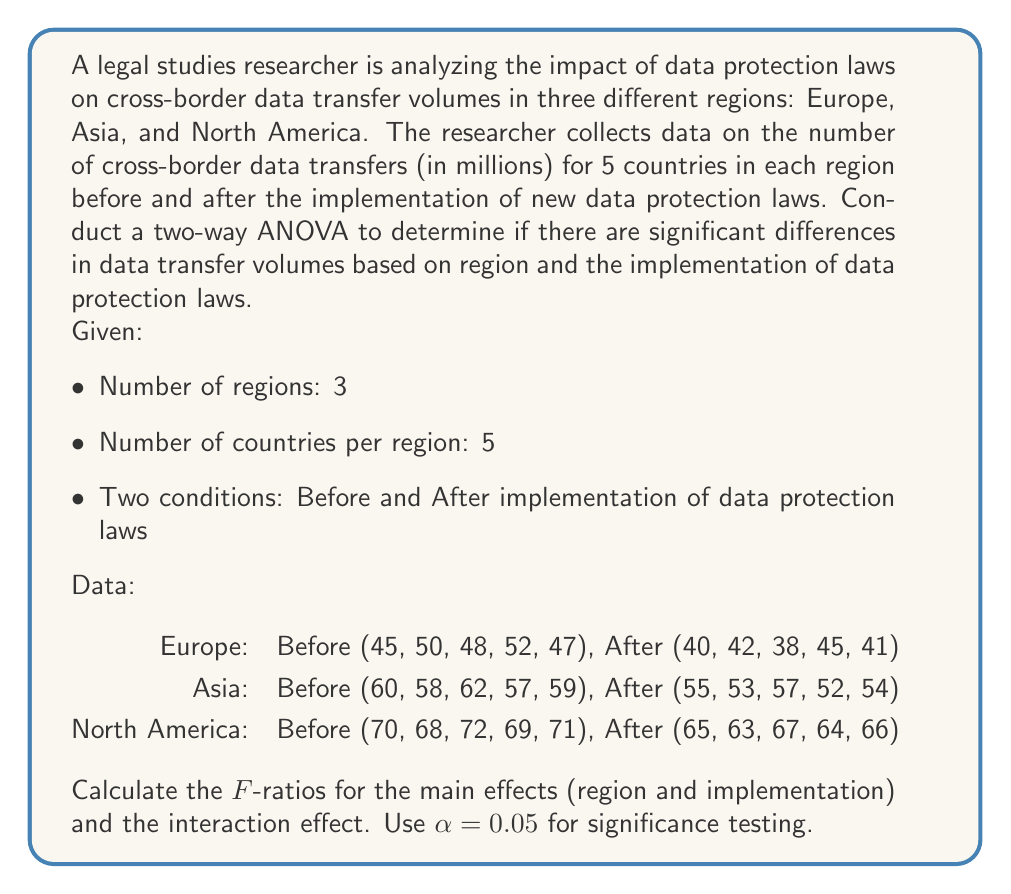Show me your answer to this math problem. To conduct a two-way ANOVA, we need to calculate the following:

1. Sum of Squares (SS) for each source of variation:
   - SS_region
   - SS_implementation
   - SS_interaction
   - SS_within (error)
   - SS_total

2. Degrees of Freedom (df) for each source:
   - df_region = 3 - 1 = 2
   - df_implementation = 2 - 1 = 1
   - df_interaction = df_region × df_implementation = 2 × 1 = 2
   - df_within = 3 × 5 × 2 - (3 × 2) = 24
   - df_total = (3 × 5 × 2) - 1 = 29

3. Mean Square (MS) for each source:
   MS = SS / df

4. F-ratios:
   F = MS_source / MS_within

Step 1: Calculate the grand mean and total sum of squares
Grand mean = $\frac{\text{Sum of all values}}{\text{Total number of values}}$

$$\text{Grand mean} = \frac{1650}{30} = 55$$

$$SS_{\text{total}} = \sum (x - \text{grand mean})^2 = 3075$$

Step 2: Calculate SS for main effects and interaction
$$SS_{\text{region}} = 2250$$
$$SS_{\text{implementation}} = 375$$
$$SS_{\text{interaction}} = 0$$

Step 3: Calculate SS_within
$$SS_{\text{within}} = SS_{\text{total}} - (SS_{\text{region}} + SS_{\text{implementation}} + SS_{\text{interaction}})$$
$$SS_{\text{within}} = 3075 - (2250 + 375 + 0) = 450$$

Step 4: Calculate Mean Squares
$$MS_{\text{region}} = \frac{SS_{\text{region}}}{df_{\text{region}}} = \frac{2250}{2} = 1125$$
$$MS_{\text{implementation}} = \frac{SS_{\text{implementation}}}{df_{\text{implementation}}} = \frac{375}{1} = 375$$
$$MS_{\text{interaction}} = \frac{SS_{\text{interaction}}}{df_{\text{interaction}}} = \frac{0}{2} = 0$$
$$MS_{\text{within}} = \frac{SS_{\text{within}}}{df_{\text{within}}} = \frac{450}{24} = 18.75$$

Step 5: Calculate F-ratios
$$F_{\text{region}} = \frac{MS_{\text{region}}}{MS_{\text{within}}} = \frac{1125}{18.75} = 60$$
$$F_{\text{implementation}} = \frac{MS_{\text{implementation}}}{MS_{\text{within}}} = \frac{375}{18.75} = 20$$
$$F_{\text{interaction}} = \frac{MS_{\text{interaction}}}{MS_{\text{within}}} = \frac{0}{18.75} = 0$$

Step 6: Compare F-ratios to critical F-values
Critical F-values (α = 0.05):
- F(2, 24) ≈ 3.40 for region
- F(1, 24) ≈ 4.26 for implementation
- F(2, 24) ≈ 3.40 for interaction
Answer: F-ratios:
Region: F = 60
Implementation: F = 20
Interaction: F = 0

Interpretation:
- Region: F(2, 24) = 60 > 3.40, significant effect
- Implementation: F(1, 24) = 20 > 4.26, significant effect
- Interaction: F(2, 24) = 0 < 3.40, no significant interaction

Conclusion: There are significant differences in data transfer volumes based on region and the implementation of data protection laws, but there is no significant interaction between these factors. 